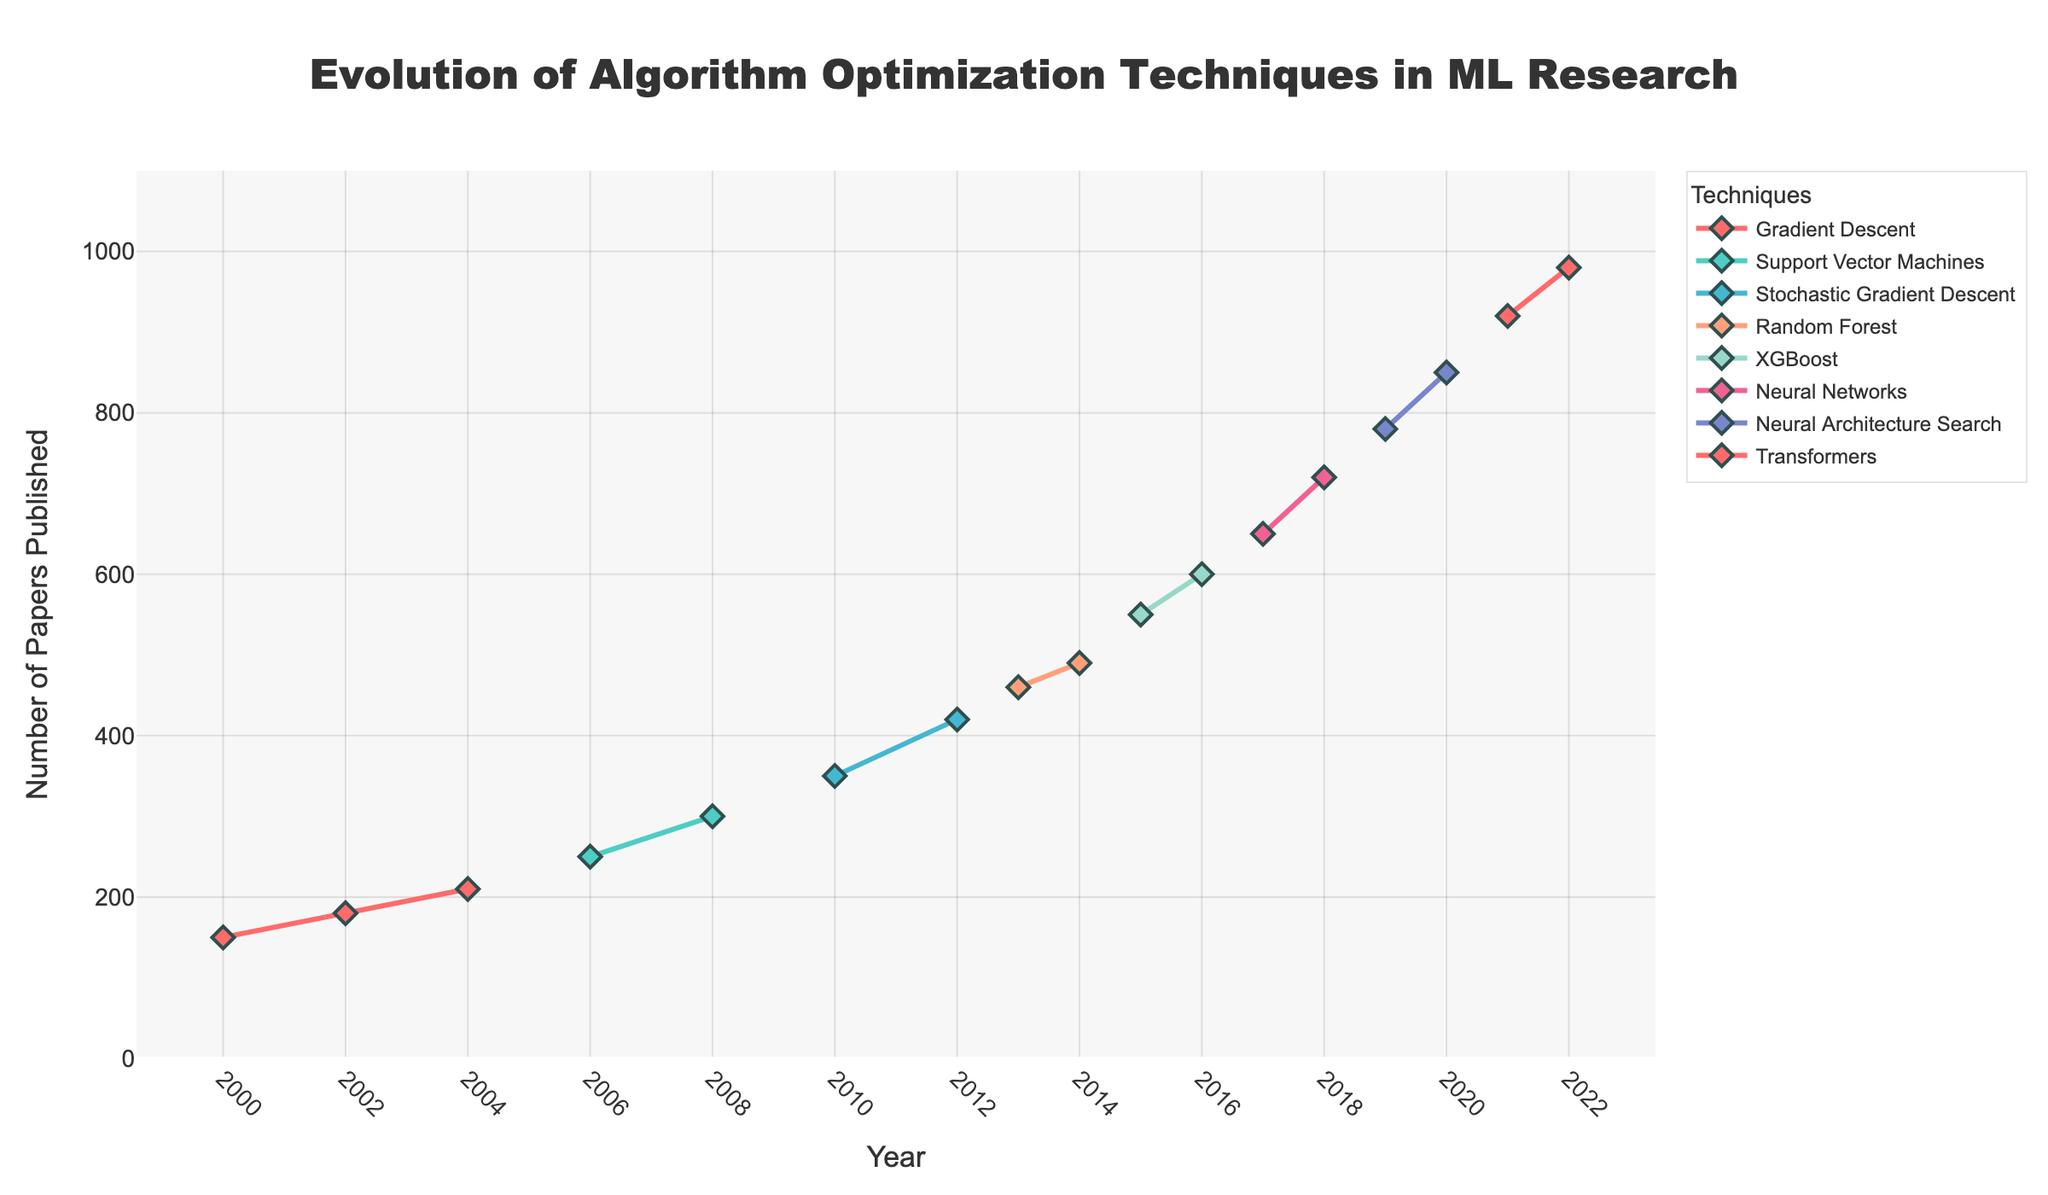What is the title of the figure? The title of a figure is often located at the top and represents the main topic or insight being visualized. In this case, it reads "Evolution of Algorithm Optimization Techniques in ML Research".
Answer: Evolution of Algorithm Optimization Techniques in ML Research What are the x-axis and y-axis labels? The x-axis represents the "Year", while the y-axis represents the "Number of Papers Published". These labels help identify what each axis quantifies.
Answer: Year, Number of Papers Published Which technique shows the highest number of papers published in 2022? Looking at the end of the time series for 2022, the "Transformers" technique has the highest peak on the y-axis, indicating the largest number of papers published.
Answer: Transformers How many techniques are plotted in the figure? Each unique line with distinct markers represents a different technique. By identifying the lines, we see there are 7 techniques.
Answer: 7 Which technique had the first noticeable increase in the number of papers published around 2010? By tracing the lines, we see "Stochastic Gradient Descent" experienced a noticeable increase around 2010.
Answer: Stochastic Gradient Descent Compare the number of papers published for Gradient Descent in 2002 and 2004, and calculate the difference. In 2002, the number is 180, and in 2004, it is 210. The difference is \(210 - 180 = 30\).
Answer: 30 Which technique had a steady increase in publications from 2015 onwards and surpassed all other techniques by 2021? Starting from 2015, "Neural Networks" steadily increased and surpassed all others by 2021.
Answer: Neural Networks How many years did it take for Neural Architecture Search to go from 780 papers in 2019 to 850 papers in 2020? It took 1 year for Neural Architecture Search to increase from 780 papers in 2019 to 850 papers in 2020.
Answer: 1 year What is the major trend for algorithm optimization techniques in machine learning research from 2000 to 2022 based on the plot? The plot shows an overall increase in the number of papers published for all techniques, indicating growing interest and development in algorithm optimization techniques over time. Each new technique tends to emerge and then surpass the older ones in publication counts.
Answer: Increasing trend Which technique was the most dominant in terms of publication count in the early 2000s? Looking at the early 2000s, "Gradient Descent" had the most papers published compared to other techniques.
Answer: Gradient Descent 